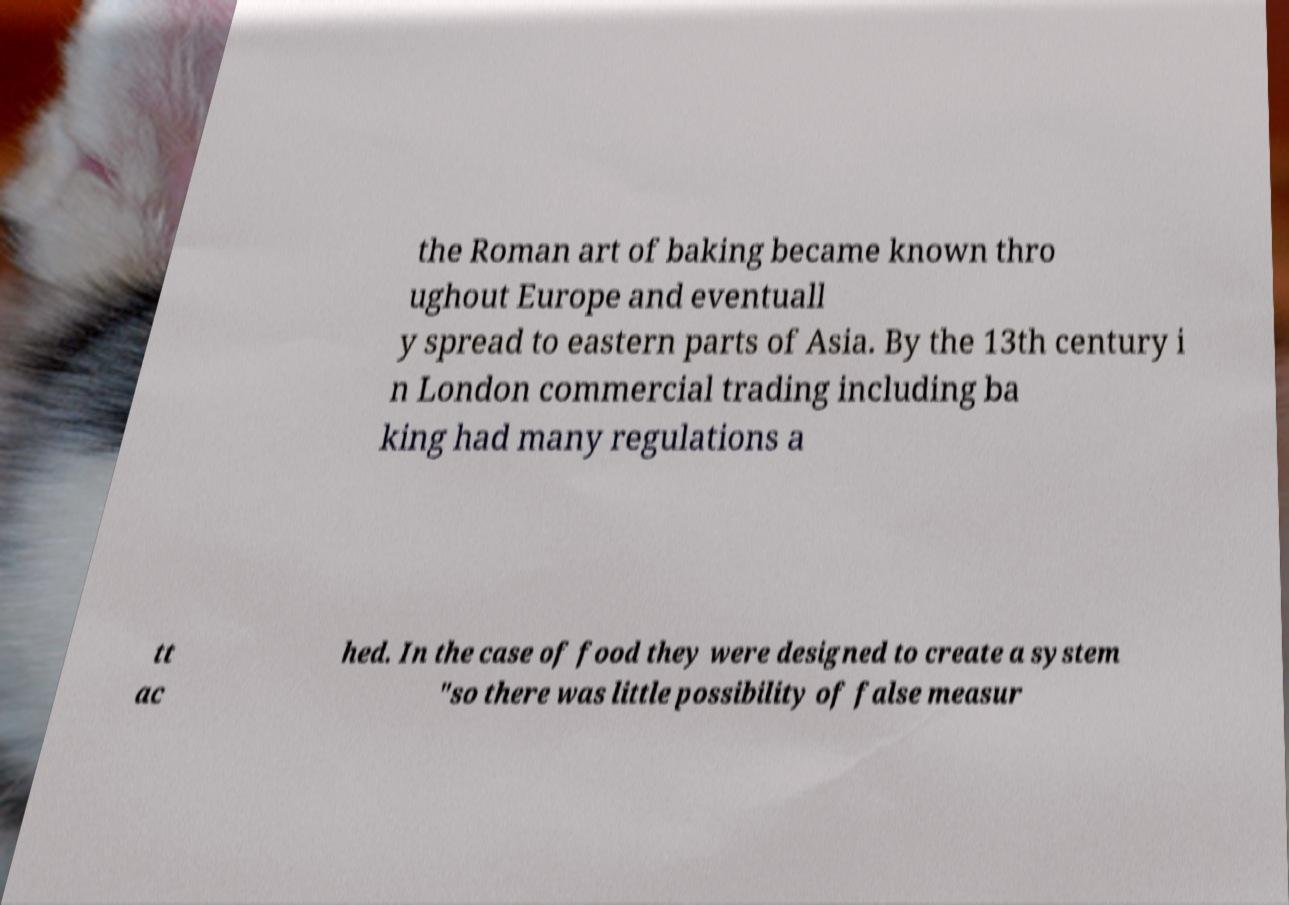For documentation purposes, I need the text within this image transcribed. Could you provide that? the Roman art of baking became known thro ughout Europe and eventuall y spread to eastern parts of Asia. By the 13th century i n London commercial trading including ba king had many regulations a tt ac hed. In the case of food they were designed to create a system "so there was little possibility of false measur 